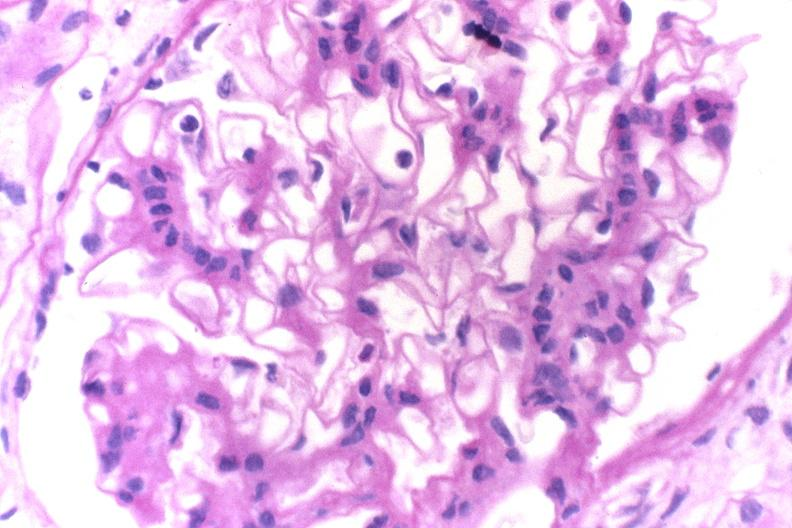where is this?
Answer the question using a single word or phrase. Urinary 